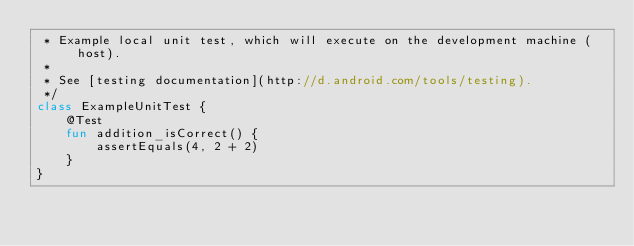<code> <loc_0><loc_0><loc_500><loc_500><_Kotlin_> * Example local unit test, which will execute on the development machine (host).
 *
 * See [testing documentation](http://d.android.com/tools/testing).
 */
class ExampleUnitTest {
    @Test
    fun addition_isCorrect() {
        assertEquals(4, 2 + 2)
    }
}
</code> 